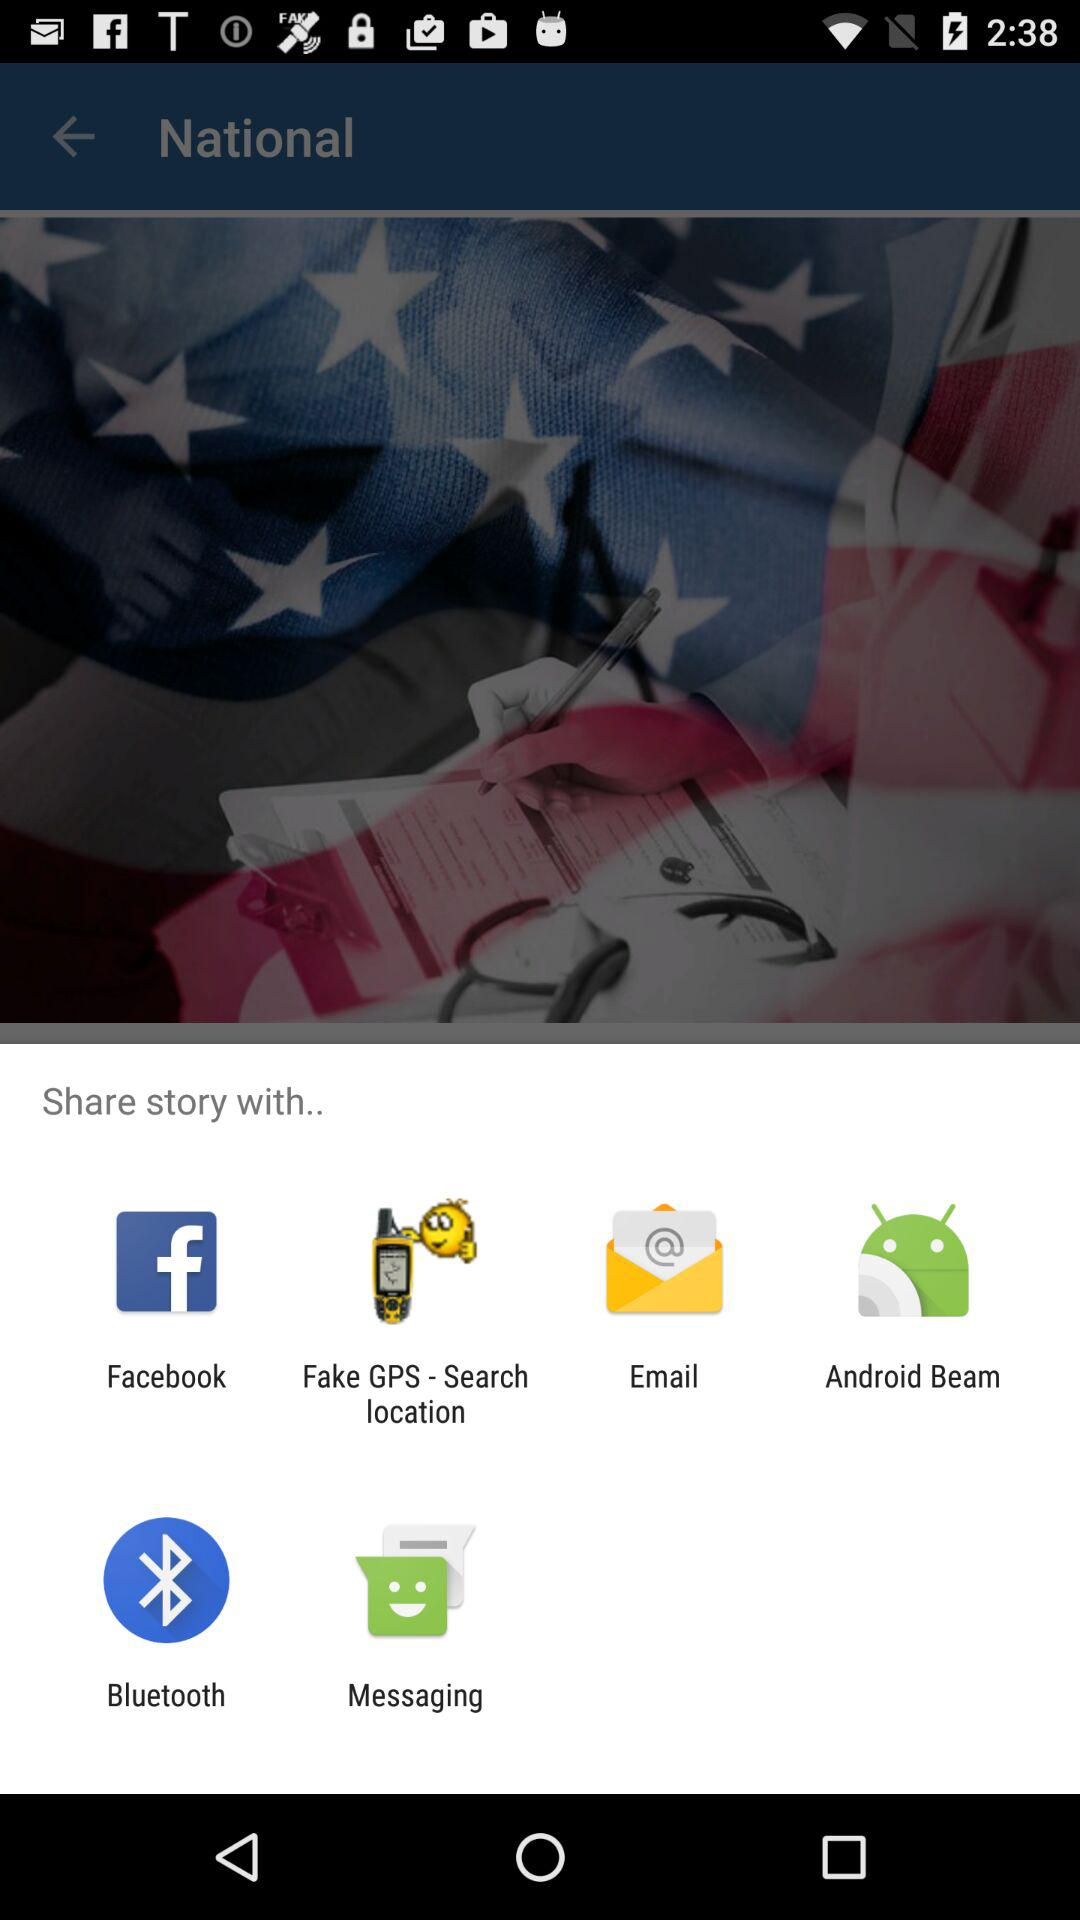What are the sharing options? The sharing options are "Facebook", "Fake GPS - Search location", "Email", "Android Beam", "Bluetooth" and "Messaging". 